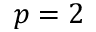Convert formula to latex. <formula><loc_0><loc_0><loc_500><loc_500>p = 2</formula> 